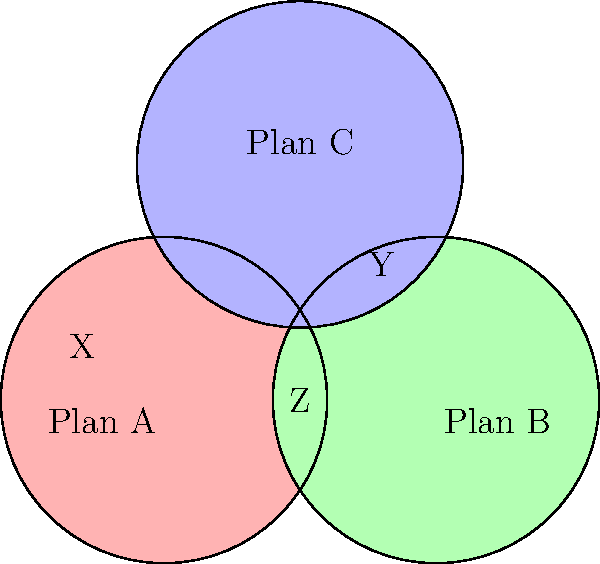In the diagram above, three overlapping circles represent the coverage areas of different health insurance plans. Each region is labeled with a letter. Which region represents the area where patients would have coverage under all three plans? To determine the region where patients would have coverage under all three plans, we need to identify the area where all three circles overlap. Let's analyze the diagram step-by-step:

1. Plan A is represented by the red circle on the left.
2. Plan B is represented by the green circle on the right.
3. Plan C is represented by the blue circle at the top.

4. Region X is only covered by Plan A.
5. Region Y is only covered by Plan C.
6. Region Z is covered by both Plan A and Plan B, but not Plan C.

7. The central region, where all three circles overlap, is not labeled with a letter. This unlabeled central region is the area where all three plans provide coverage.

8. Patients in this central region would be covered by Plan A, Plan B, and Plan C simultaneously.

Therefore, the region representing coverage under all three plans is the unlabeled central area where all three circles intersect.
Answer: The unlabeled central region 